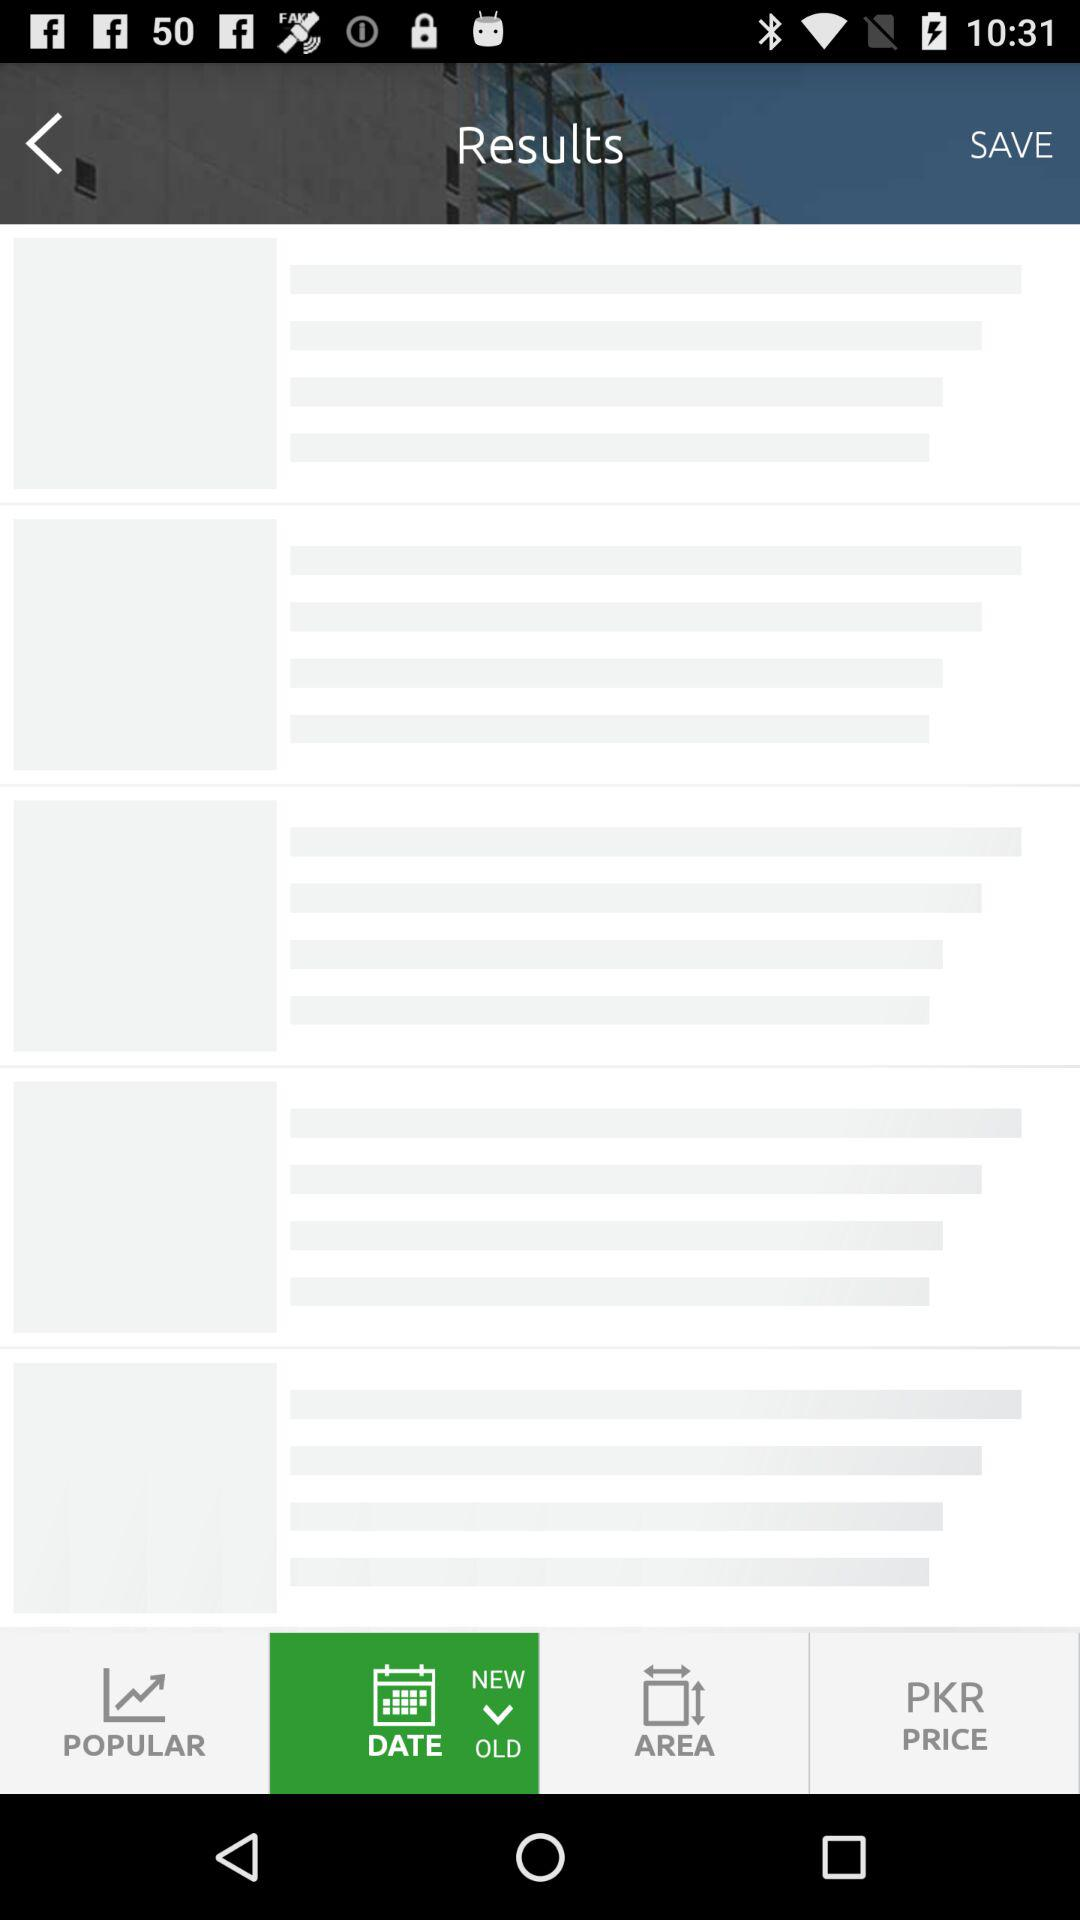What is the property ID? The property ID is 4455918. 